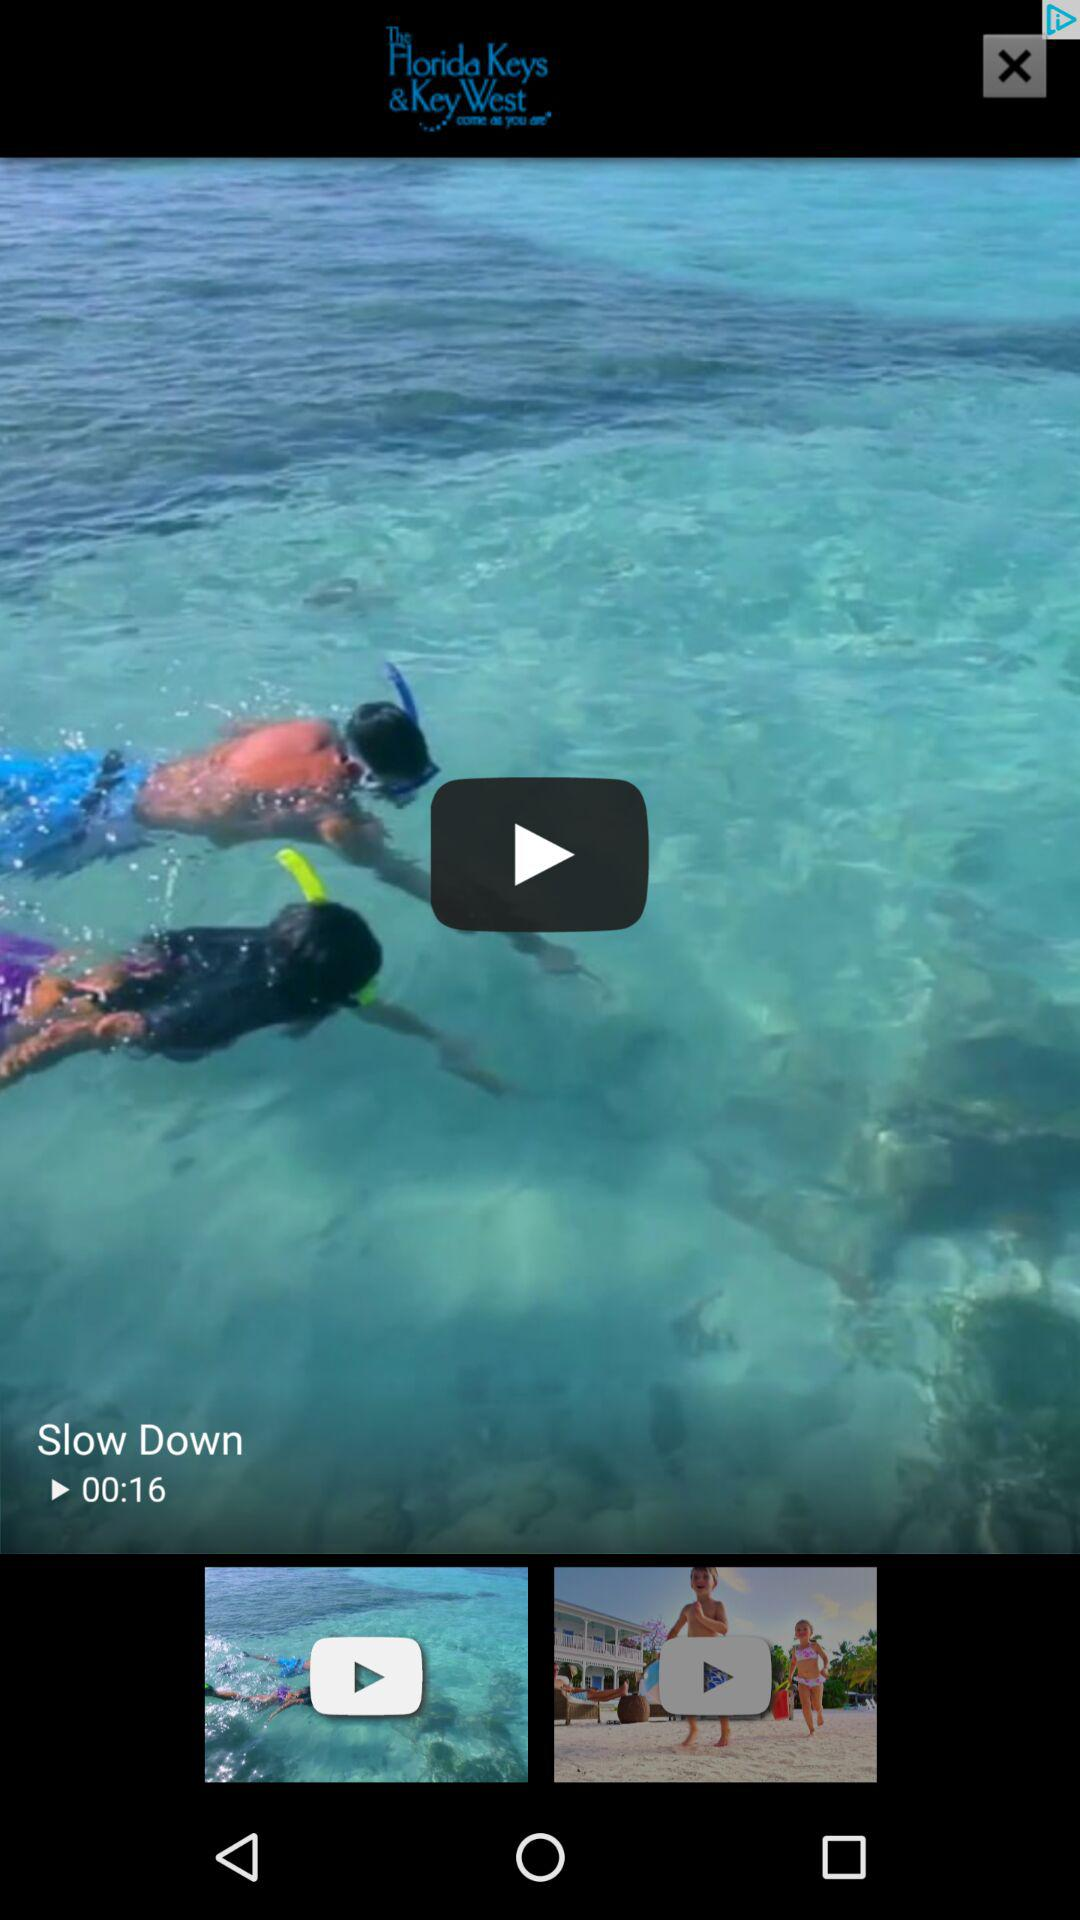What's the length of the video? The length of the video is 16 seconds. 